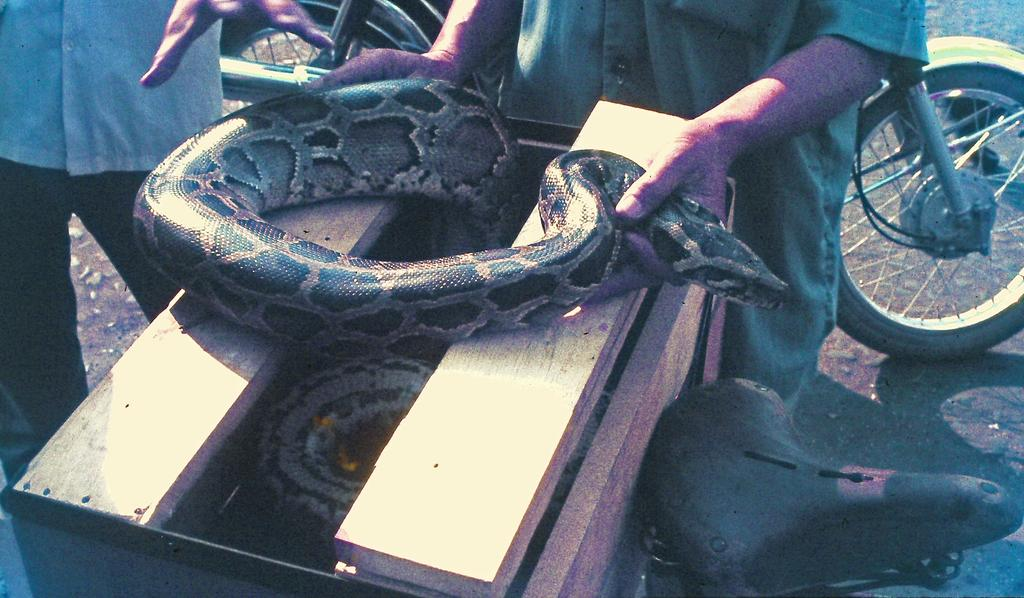What is the main subject of the image? There is a person in the image. What is the person holding in his hand? The person is holding a snake in his hand. Where is the snake located? The snake is on a wooden box. What is the wooden box placed on? The wooden box is on a bicycle. Can you describe the person in the background of the image? There is a person in the background of the image, and he is on the ground. What is visible in the background of the image? The ground is visible in the background of the image. What type of butter is being spread on the tomatoes in the image? There is no butter or tomatoes present in the image. Is there a glove visible in the image? No, there is no glove visible in the image. 